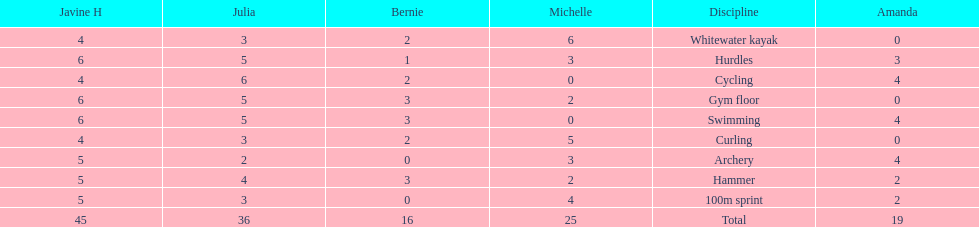Who is the faster runner? Javine H. 